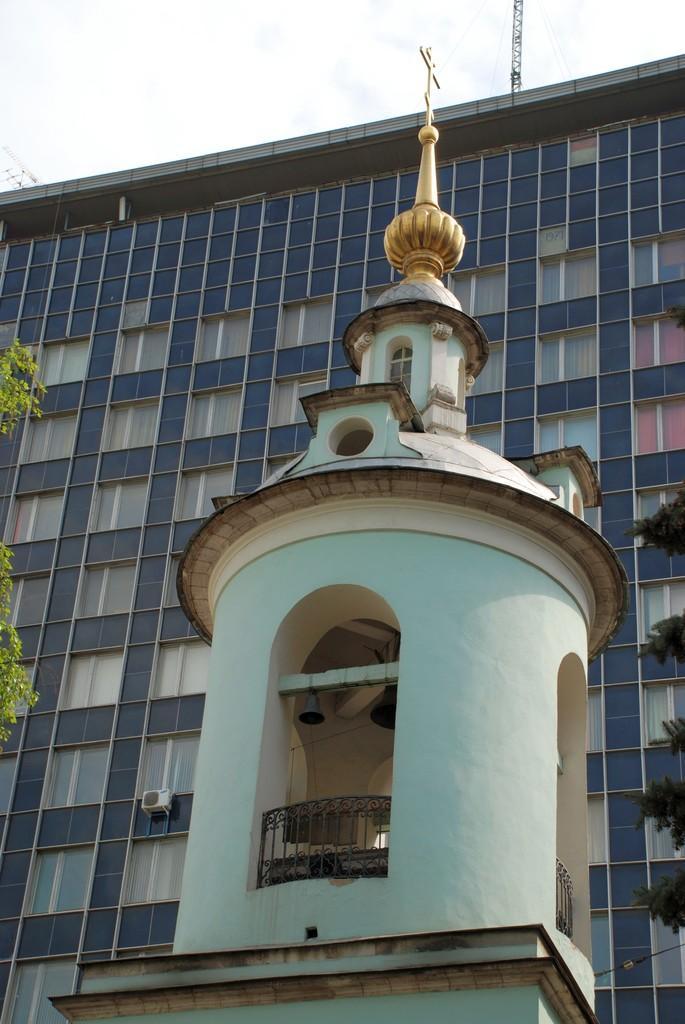In one or two sentences, can you explain what this image depicts? In this picture I can see a tower in front and on the left side of this picture I can see the leaves. In the background I can see a building and the sky. On the right side of this picture I can see many more leaves. 